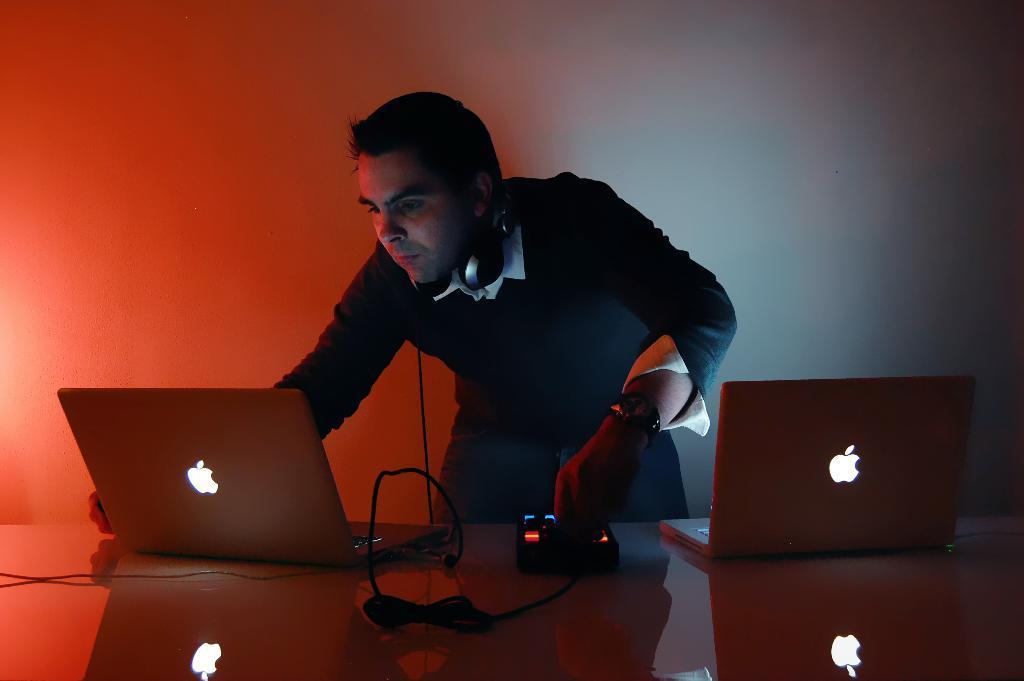Can you describe this image briefly? Here we see a man operating laptop on a laptop we see other laptop on the side 